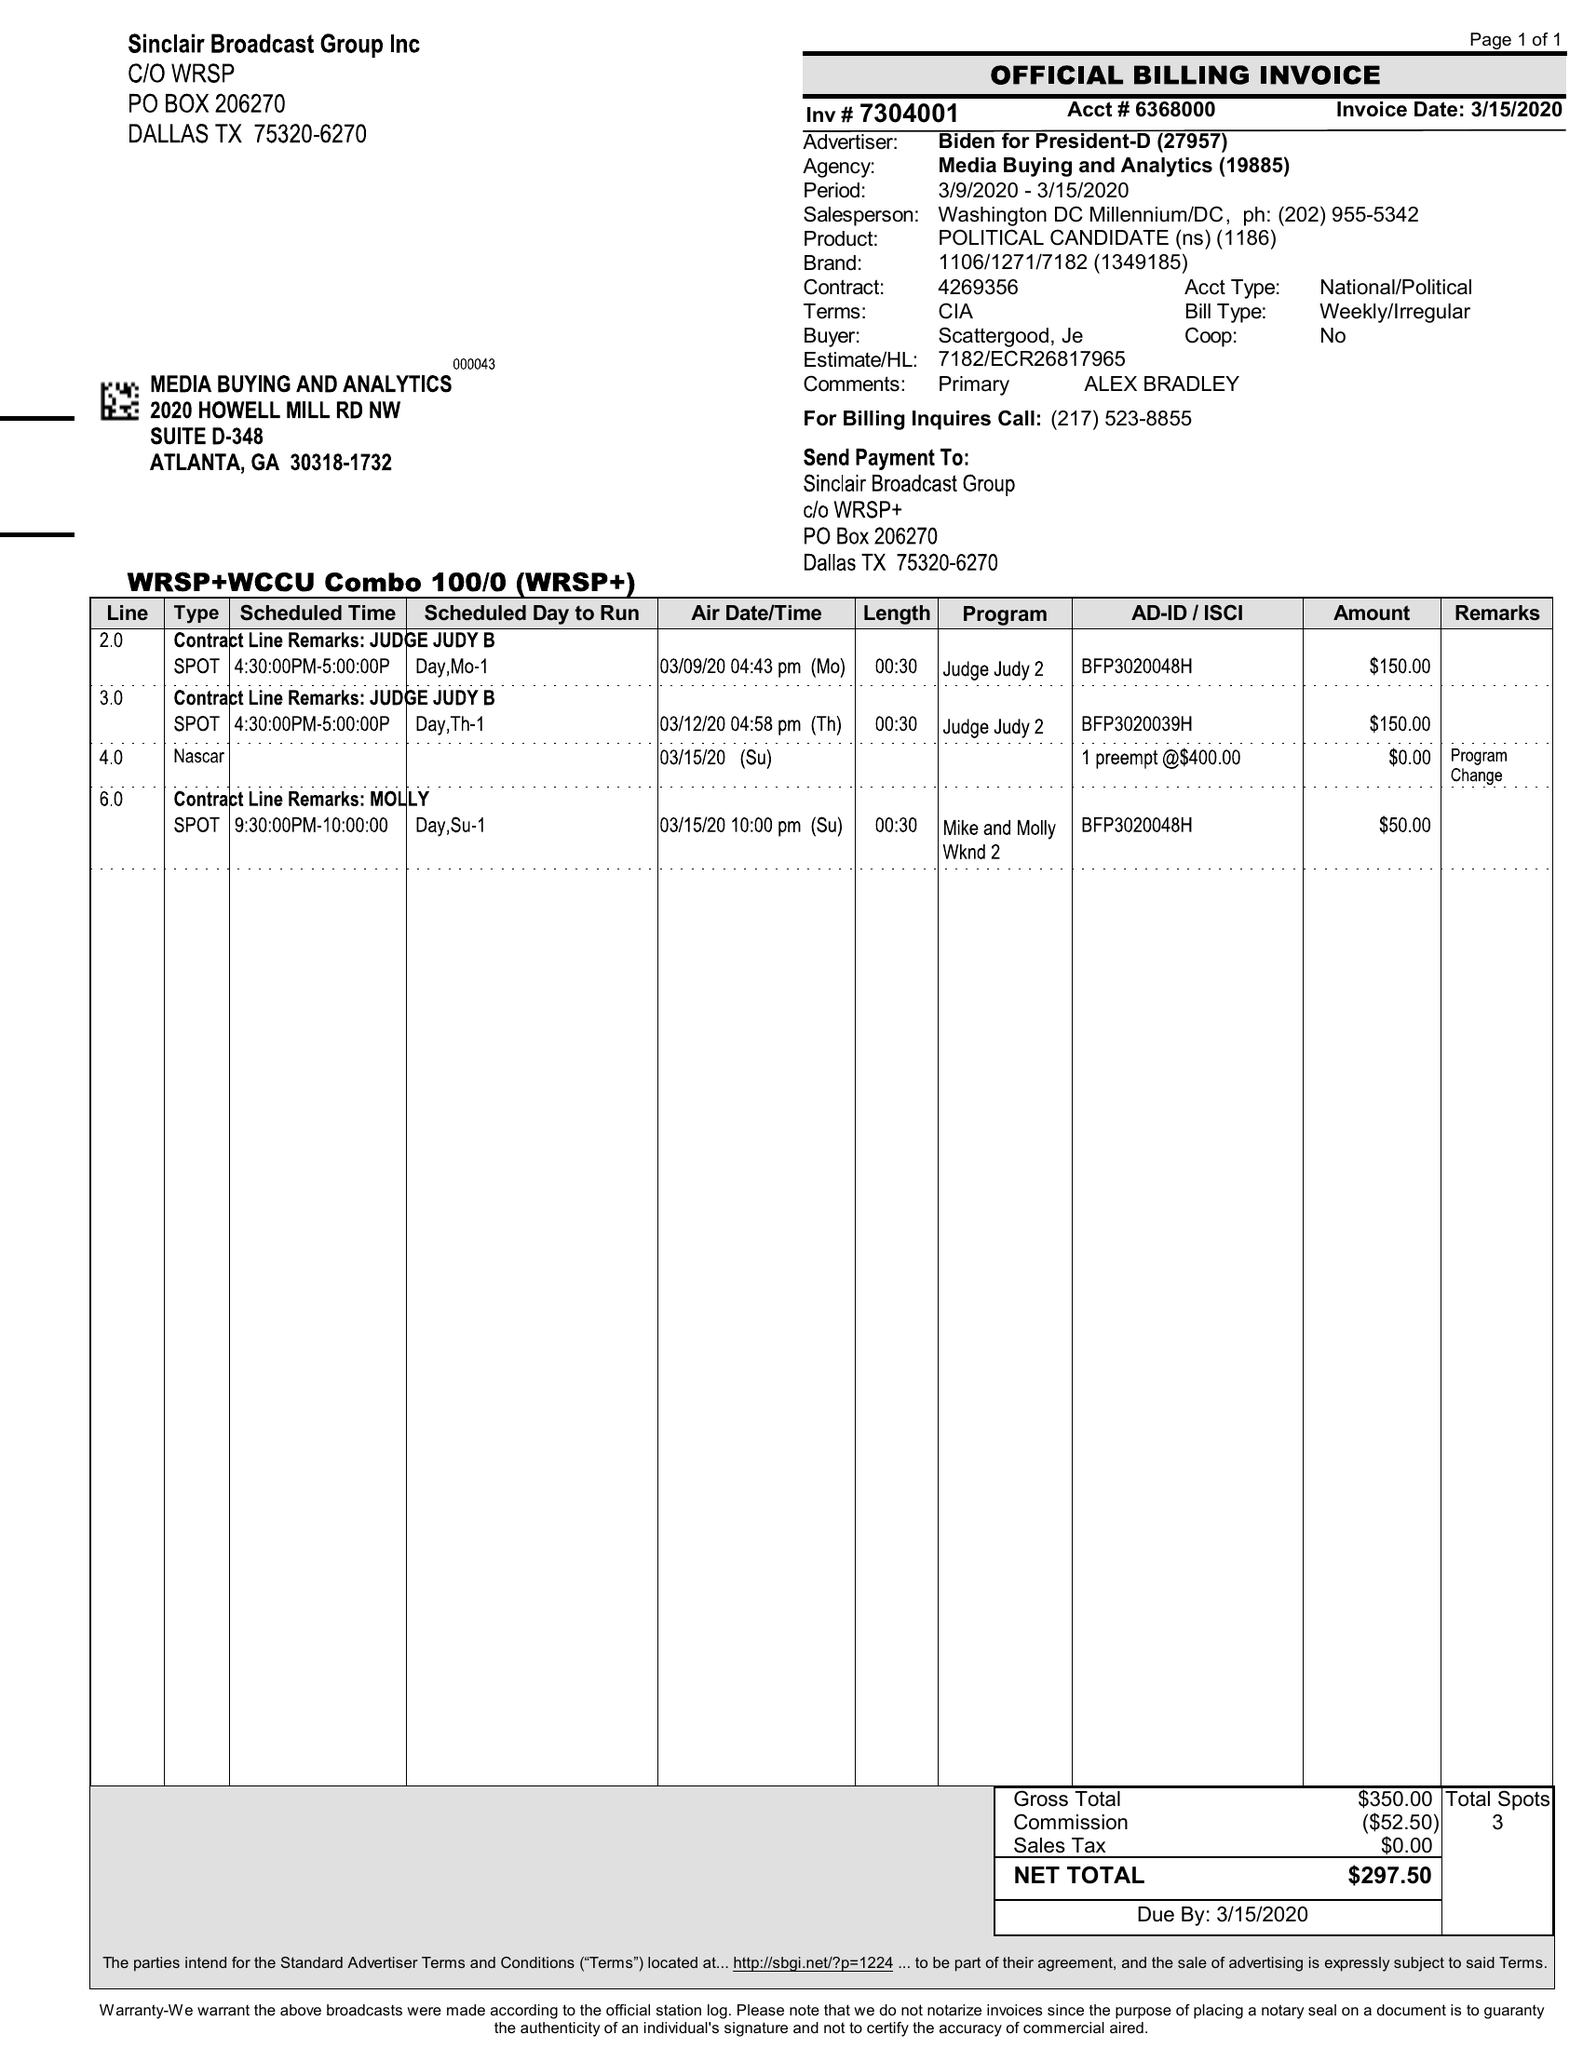What is the value for the advertiser?
Answer the question using a single word or phrase. BIDEN FOR PRESIDENT-D 